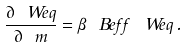<formula> <loc_0><loc_0><loc_500><loc_500>\frac { \partial \ W e q } { \partial \ m } = \beta \ B e f f \, \ W e q \, .</formula> 